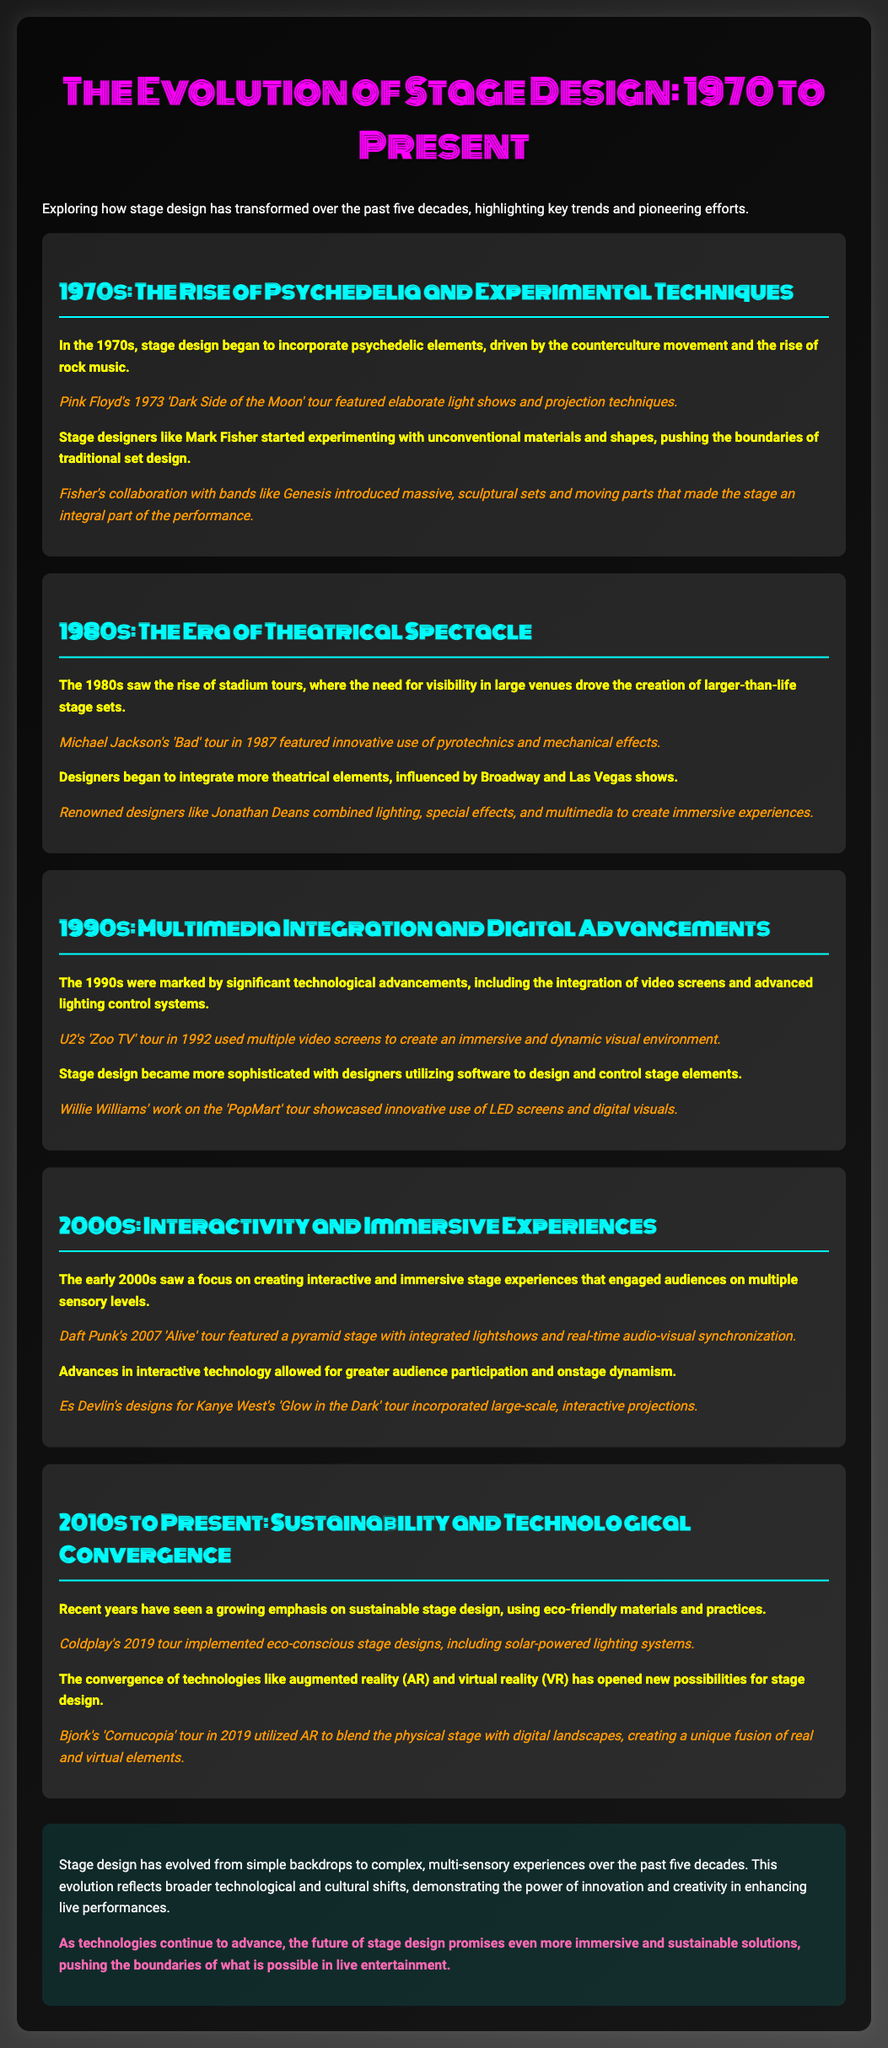What influence did the 1970s counterculture have on stage design? The 1970s counterculture movement drove the incorporation of psychedelic elements in stage design.
Answer: Psychedelic elements Which band is mentioned regarding the 1973 'Dark Side of the Moon' tour? Pink Floyd is referenced for their 1973 tour featuring elaborate light shows and projection techniques.
Answer: Pink Floyd What year did Michael Jackson's 'Bad' tour take place? The document specifies that Michael Jackson's 'Bad' tour occurred in 1987.
Answer: 1987 Who is credited with innovative use of LED screens in the 90s? Willie Williams is acknowledged for showcasing innovative use of LED screens during the 'PopMart' tour.
Answer: Willie Williams Which band utilized augmented reality in their 2019 tour? Bjork's 'Cornucopia' tour in 2019 is noted for utilizing augmented reality.
Answer: Bjork What was a key trend in stage design during the 2000s? A focus on creating interactive and immersive stage experiences characterized the 2000s.
Answer: Interactivity Who collaborated with bands like Genesis in the 1970s? Mark Fisher is recognized for experimenting with unconventional materials and shapes.
Answer: Mark Fisher What significant aspect of stage design became prominent in recent years? A growing emphasis on sustainable stage design has emerged.
Answer: Sustainability Which tour is mentioned as featuring a pyramid stage? Daft Punk's 2007 'Alive' tour is cited for its pyramid stage design.
Answer: Daft Punk's 'Alive' tour 